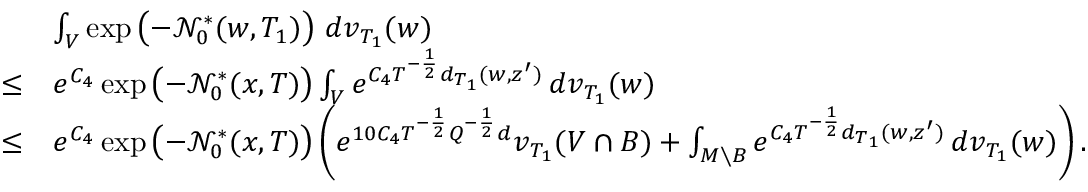Convert formula to latex. <formula><loc_0><loc_0><loc_500><loc_500>\begin{array} { r l } & { \int _ { V } \exp \left ( - { \mathcal { N } } _ { 0 } ^ { * } ( w , T _ { 1 } ) \right ) \, d v _ { T _ { 1 } } ( w ) } \\ { \leq } & { e ^ { C _ { 4 } } \exp \left ( - { \mathcal { N } } _ { 0 } ^ { * } ( x , T ) \right ) \int _ { V } e ^ { C _ { 4 } T ^ { - \frac { 1 } { 2 } } d _ { T _ { 1 } } ( w , z ^ { \prime } ) } \, d v _ { T _ { 1 } } ( w ) } \\ { \leq } & { e ^ { C _ { 4 } } \exp \left ( - { \mathcal { N } } _ { 0 } ^ { * } ( x , T ) \right ) \left ( e ^ { 1 0 C _ { 4 } T ^ { - \frac { 1 } { 2 } } Q ^ { - \frac { 1 } { 2 } } d } v _ { T _ { 1 } } ( V \cap B ) + \int _ { M \ B } e ^ { C _ { 4 } T ^ { - \frac { 1 } { 2 } } d _ { T _ { 1 } } ( w , z ^ { \prime } ) } \, d v _ { T _ { 1 } } ( w ) \right ) . } \end{array}</formula> 